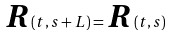<formula> <loc_0><loc_0><loc_500><loc_500>\boldsymbol R ( t , s + L ) = \boldsymbol R ( t , s )</formula> 